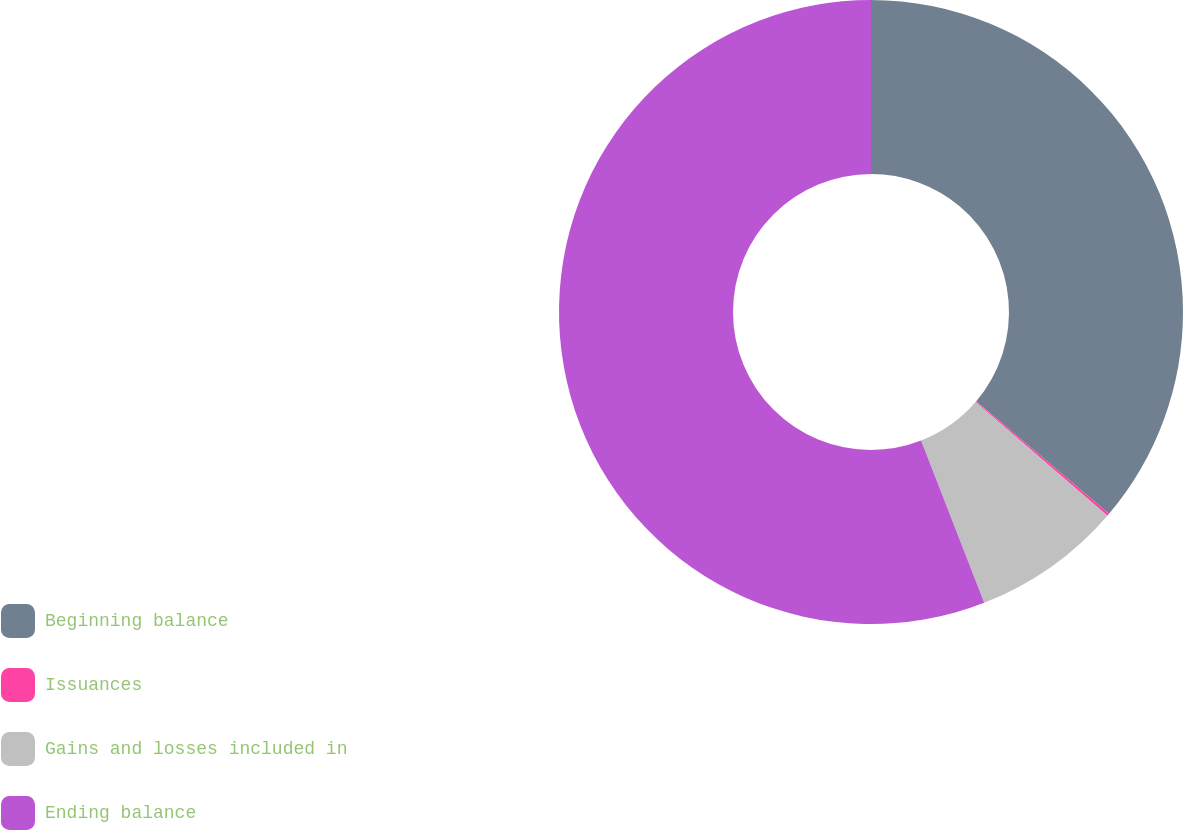Convert chart. <chart><loc_0><loc_0><loc_500><loc_500><pie_chart><fcel>Beginning balance<fcel>Issuances<fcel>Gains and losses included in<fcel>Ending balance<nl><fcel>36.19%<fcel>0.13%<fcel>7.77%<fcel>55.91%<nl></chart> 